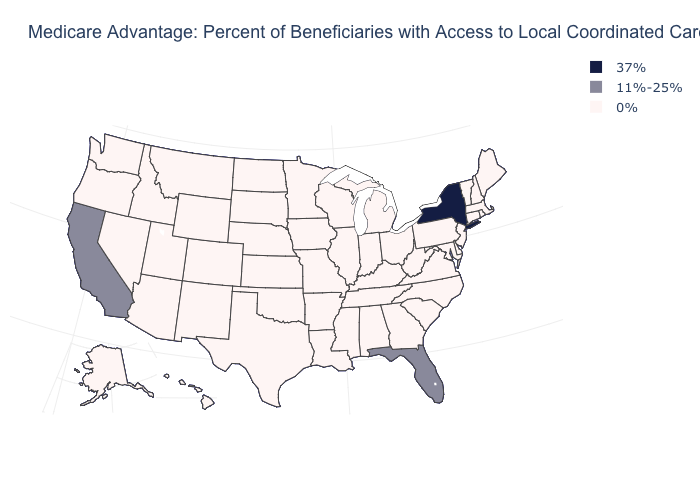What is the value of New Hampshire?
Write a very short answer. 0%. How many symbols are there in the legend?
Answer briefly. 3. Name the states that have a value in the range 0%?
Keep it brief. Alaska, Alabama, Arkansas, Arizona, Colorado, Connecticut, Delaware, Georgia, Hawaii, Iowa, Idaho, Illinois, Indiana, Kansas, Kentucky, Louisiana, Massachusetts, Maryland, Maine, Michigan, Minnesota, Missouri, Mississippi, Montana, North Carolina, North Dakota, Nebraska, New Hampshire, New Jersey, New Mexico, Nevada, Ohio, Oklahoma, Oregon, Pennsylvania, Rhode Island, South Carolina, South Dakota, Tennessee, Texas, Utah, Virginia, Vermont, Washington, Wisconsin, West Virginia, Wyoming. Among the states that border Nevada , which have the highest value?
Answer briefly. California. Does the first symbol in the legend represent the smallest category?
Write a very short answer. No. Name the states that have a value in the range 37%?
Concise answer only. New York. What is the lowest value in the USA?
Quick response, please. 0%. What is the value of Mississippi?
Quick response, please. 0%. What is the value of South Dakota?
Keep it brief. 0%. Does Georgia have the same value as Washington?
Quick response, please. Yes. What is the value of New Hampshire?
Short answer required. 0%. Name the states that have a value in the range 0%?
Give a very brief answer. Alaska, Alabama, Arkansas, Arizona, Colorado, Connecticut, Delaware, Georgia, Hawaii, Iowa, Idaho, Illinois, Indiana, Kansas, Kentucky, Louisiana, Massachusetts, Maryland, Maine, Michigan, Minnesota, Missouri, Mississippi, Montana, North Carolina, North Dakota, Nebraska, New Hampshire, New Jersey, New Mexico, Nevada, Ohio, Oklahoma, Oregon, Pennsylvania, Rhode Island, South Carolina, South Dakota, Tennessee, Texas, Utah, Virginia, Vermont, Washington, Wisconsin, West Virginia, Wyoming. Name the states that have a value in the range 11%-25%?
Write a very short answer. California, Florida. Does Kansas have the highest value in the USA?
Keep it brief. No. 